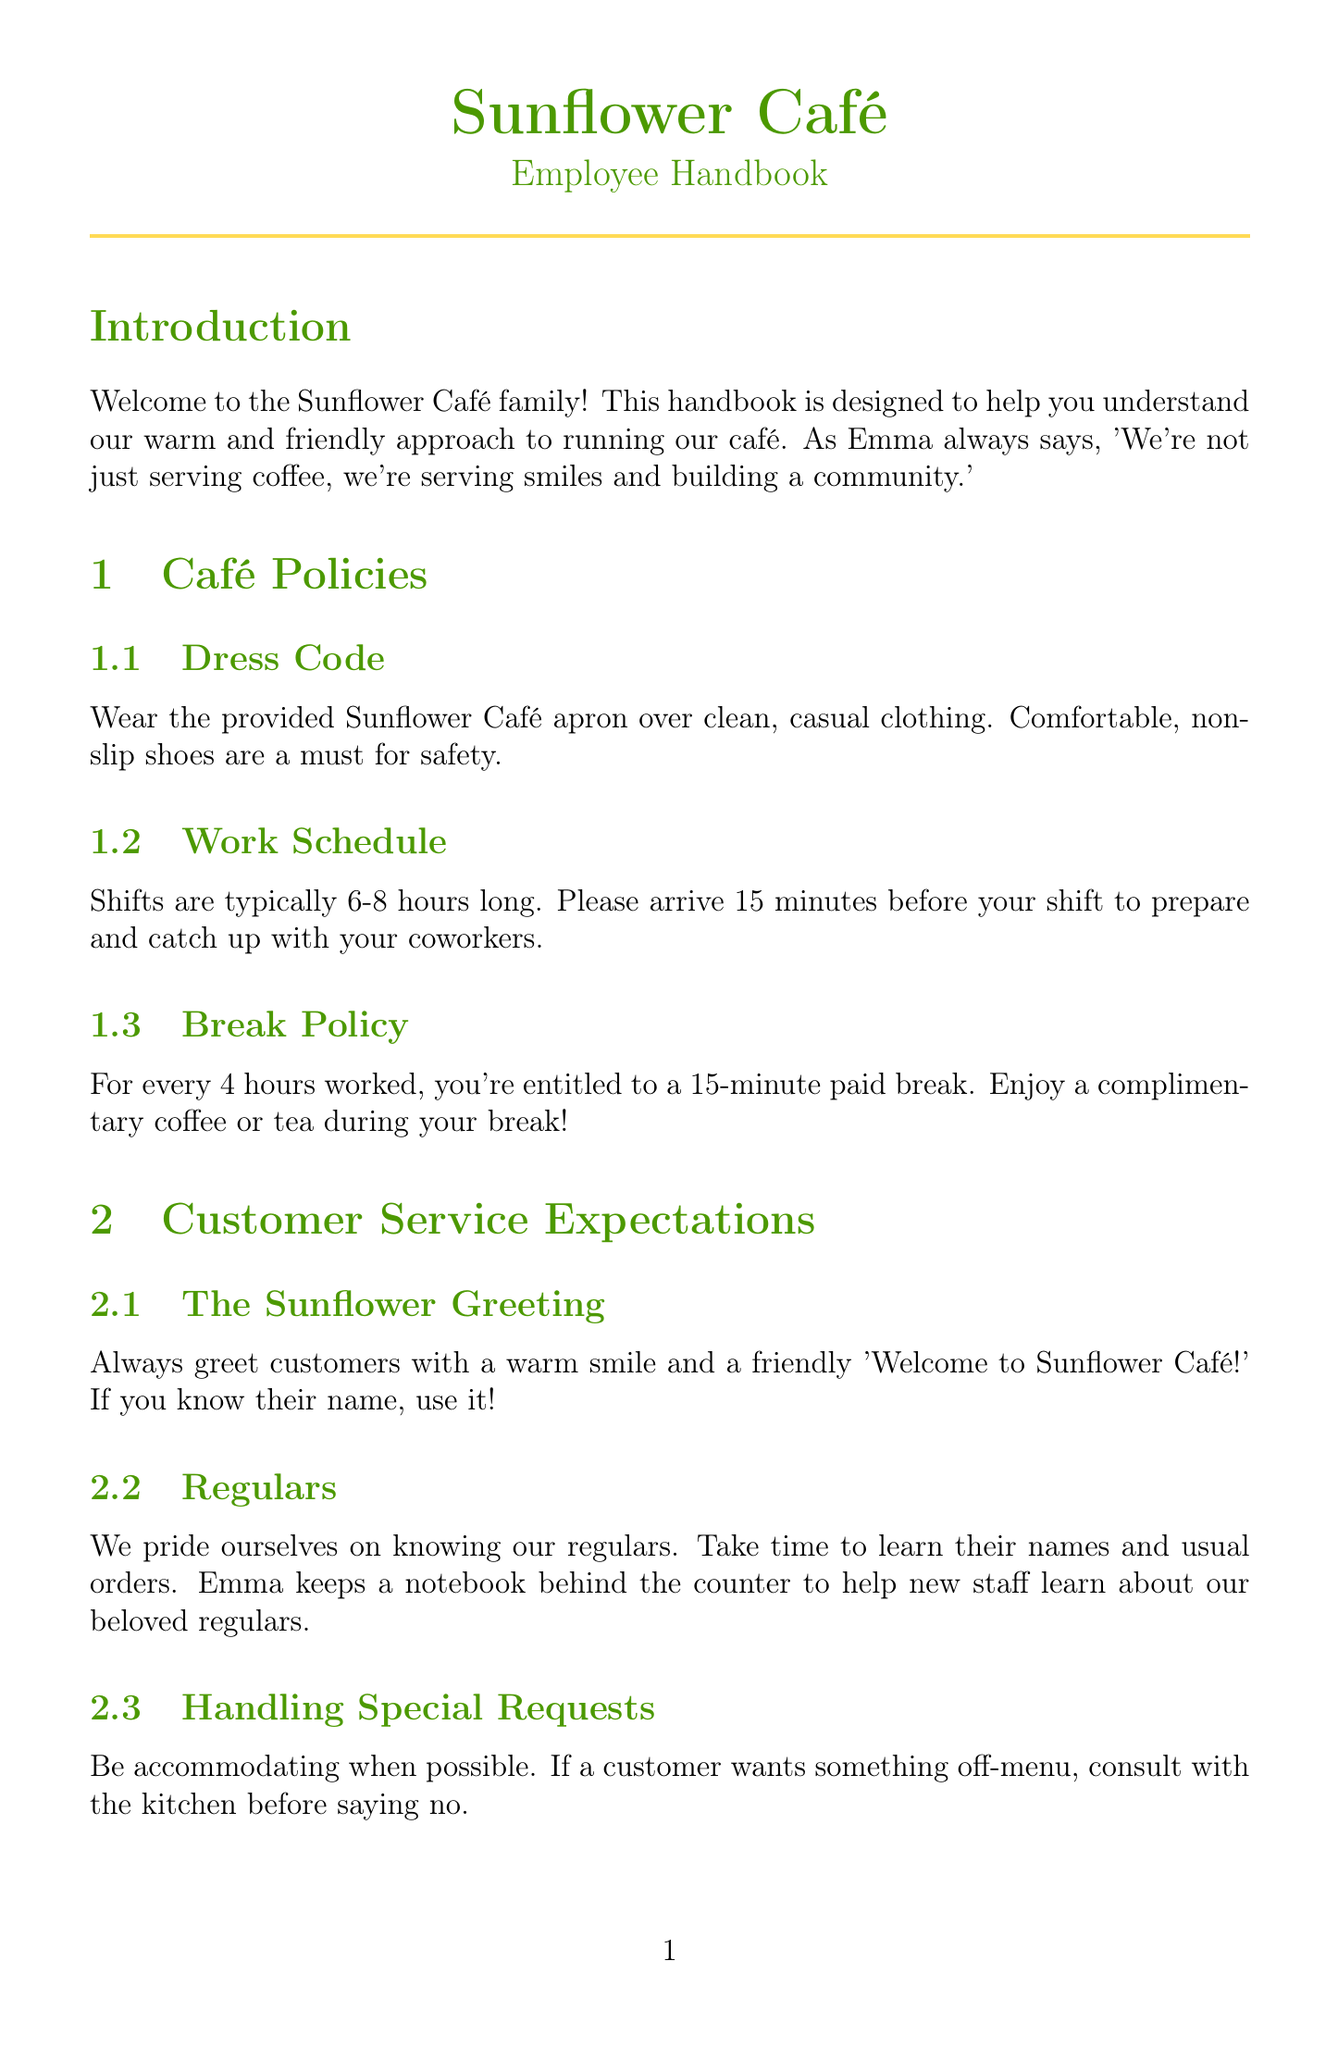What is the location of Sunflower Café? The location is provided in the café info section of the document.
Answer: 123 Main Street, Pleasantville Who is the owner of Sunflower Café? The owner's name appears in the café info section of the document.
Answer: Emma Thompson What kind of shoes should be worn according to the dress code? The dress code specifies the type of footwear staff should wear.
Answer: Non-slip shoes How long is a typical shift at the café? The work schedule section mentions the length of a regular shift.
Answer: 6-8 hours What is offered during the break policy? The break policy gives details on what employees can enjoy during breaks.
Answer: Complimentary coffee or tea What should you do if a customer is unhappy? The handling difficult situations section outlines the first step for addressing unhappy customers.
Answer: Listen actively How often do team building potlucks occur? The section on maintaining a positive work environment specifies the frequency of potluck dinners.
Answer: Monthly What title is given to the employee recognized for outstanding performance? Recognition program details what the celebrated employee is called.
Answer: Sunflower Star What is the emergency phone number to call in case of a serious injury? The first aid section indicates the appropriate number for emergencies.
Answer: 911 